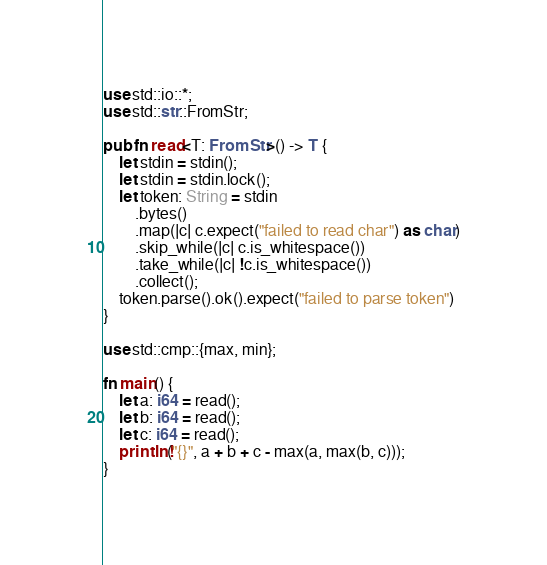Convert code to text. <code><loc_0><loc_0><loc_500><loc_500><_Rust_>use std::io::*;
use std::str::FromStr;

pub fn read<T: FromStr>() -> T {
    let stdin = stdin();
    let stdin = stdin.lock();
    let token: String = stdin
        .bytes()
        .map(|c| c.expect("failed to read char") as char)
        .skip_while(|c| c.is_whitespace())
        .take_while(|c| !c.is_whitespace())
        .collect();
    token.parse().ok().expect("failed to parse token")
}

use std::cmp::{max, min};

fn main() {
    let a: i64 = read();
    let b: i64 = read();
    let c: i64 = read();
    println!("{}", a + b + c - max(a, max(b, c)));
}
</code> 